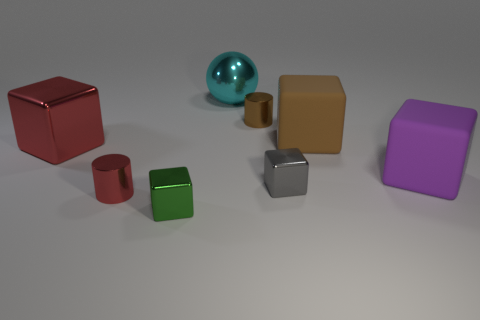Add 2 red cylinders. How many objects exist? 10 Subtract 1 cylinders. How many cylinders are left? 1 Subtract all yellow cylinders. Subtract all brown spheres. How many cylinders are left? 2 Subtract all purple cylinders. How many gray balls are left? 0 Subtract all small gray metal balls. Subtract all large brown cubes. How many objects are left? 7 Add 8 red shiny things. How many red shiny things are left? 10 Add 3 tiny cyan spheres. How many tiny cyan spheres exist? 3 Subtract all red cylinders. How many cylinders are left? 1 Subtract all red cubes. How many cubes are left? 4 Subtract 0 green spheres. How many objects are left? 8 